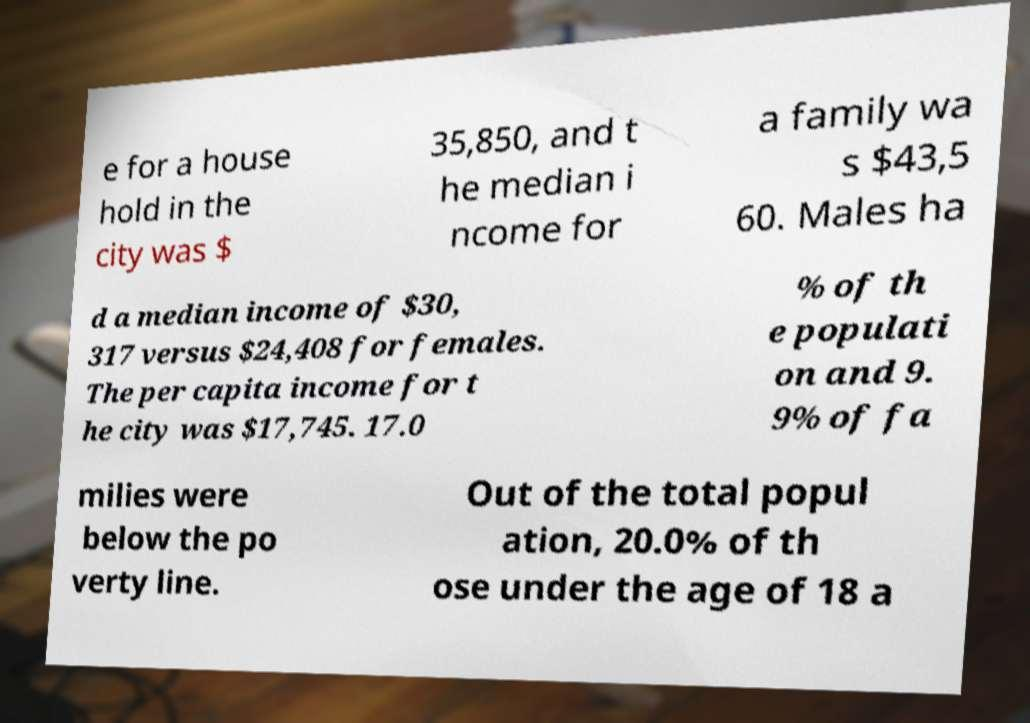There's text embedded in this image that I need extracted. Can you transcribe it verbatim? e for a house hold in the city was $ 35,850, and t he median i ncome for a family wa s $43,5 60. Males ha d a median income of $30, 317 versus $24,408 for females. The per capita income for t he city was $17,745. 17.0 % of th e populati on and 9. 9% of fa milies were below the po verty line. Out of the total popul ation, 20.0% of th ose under the age of 18 a 